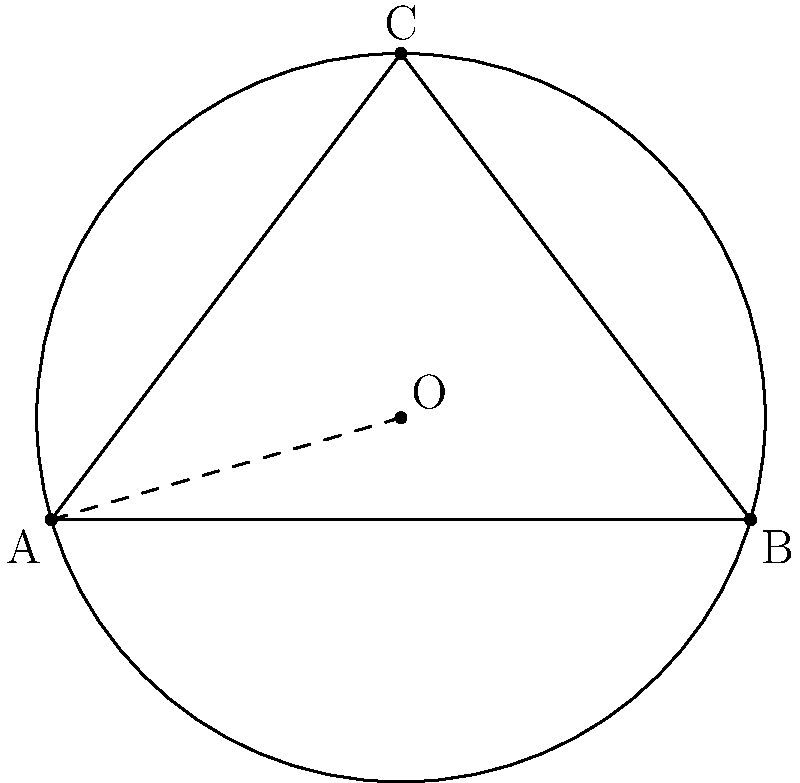In a fantasy novel, three magical artifacts form a triangular formation. The first artifact is at point A(0,0), the second at B(6,0), and the third at C(3,4). A protective magical barrier needs to be created in the shape of a circle that passes through all three artifacts. What is the radius of this circular barrier? To find the radius of the circle that circumscribes the triangle, we need to follow these steps:

1) First, we need to find the center of the circumscribed circle. This point is called the circumcenter and is located at the intersection of the perpendicular bisectors of the triangle's sides.

2) We can use the formula for the circumradius of a triangle:

   $$R = \frac{abc}{4A}$$

   where $R$ is the radius, $a$, $b$, and $c$ are the side lengths of the triangle, and $A$ is the area of the triangle.

3) Let's calculate the side lengths:
   
   $AB = 6$
   $BC = \sqrt{(3-6)^2 + (4-0)^2} = 5$
   $AC = \sqrt{3^2 + 4^2} = 5$

4) Now, let's calculate the area using Heron's formula:
   
   $s = \frac{a+b+c}{2} = \frac{6+5+5}{2} = 8$
   
   $A = \sqrt{s(s-a)(s-b)(s-c)}$
   $A = \sqrt{8(8-6)(8-5)(8-5)} = \sqrt{8 \cdot 2 \cdot 3 \cdot 3} = \sqrt{144} = 12$

5) Now we can plug these values into our circumradius formula:

   $$R = \frac{6 \cdot 5 \cdot 5}{4 \cdot 12} = \frac{150}{48} = \frac{25}{8} = 3.125$$

Therefore, the radius of the circular magical barrier is 3.125 units.
Answer: 3.125 units 